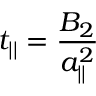<formula> <loc_0><loc_0><loc_500><loc_500>t _ { | | } = \frac { B _ { 2 } } { a _ { | | } ^ { 2 } }</formula> 